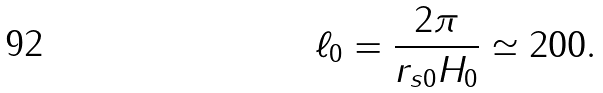Convert formula to latex. <formula><loc_0><loc_0><loc_500><loc_500>\ell _ { 0 } = \frac { 2 \pi } { r _ { s 0 } H _ { 0 } } \simeq 2 0 0 .</formula> 